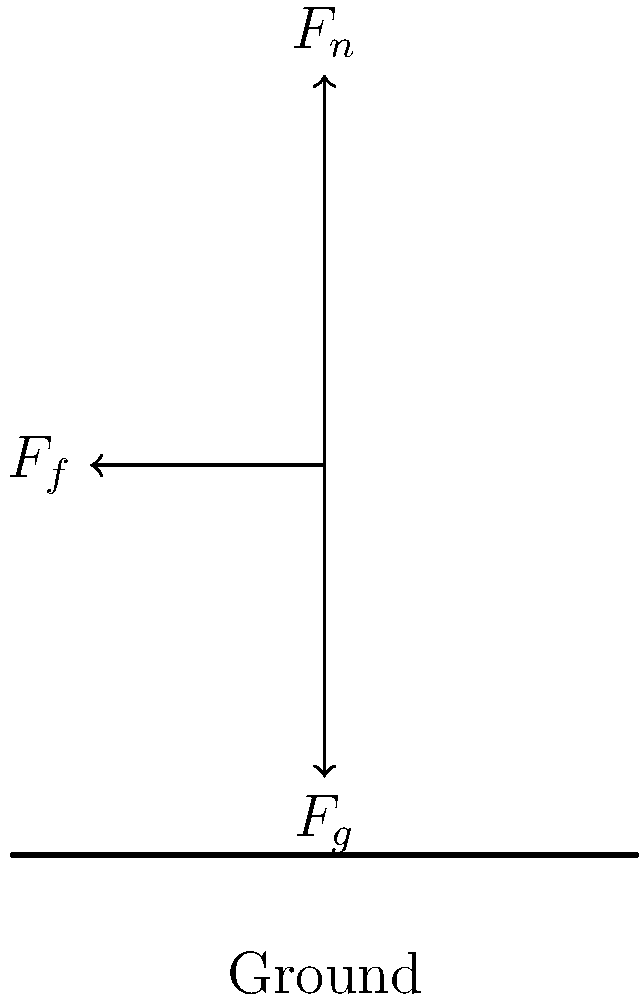Given the force vector diagram for a runner's foot during ground contact, calculate the magnitude of the resultant force acting on the foot. Assume $F_g = 600$ N, $F_n = 750$ N, and $F_f = 450$ N. To solve this problem, we'll use the following steps:

1. Identify the forces:
   $F_g$ (gravity force): 600 N downward
   $F_n$ (normal force): 750 N upward
   $F_f$ (friction force): 450 N horizontal (opposite to motion direction)

2. Resolve forces into x and y components:
   x-component: $F_x = F_f = -450$ N
   y-component: $F_y = F_n - F_g = 750 - 600 = 150$ N

3. Calculate the resultant force using the Pythagorean theorem:
   $F_R = \sqrt{F_x^2 + F_y^2}$

4. Substitute the values:
   $F_R = \sqrt{(-450)^2 + (150)^2}$

5. Compute the result:
   $F_R = \sqrt{202500 + 22500} = \sqrt{225000} = 474.34$ N

Therefore, the magnitude of the resultant force acting on the runner's foot is approximately 474.34 N.
Answer: 474.34 N 